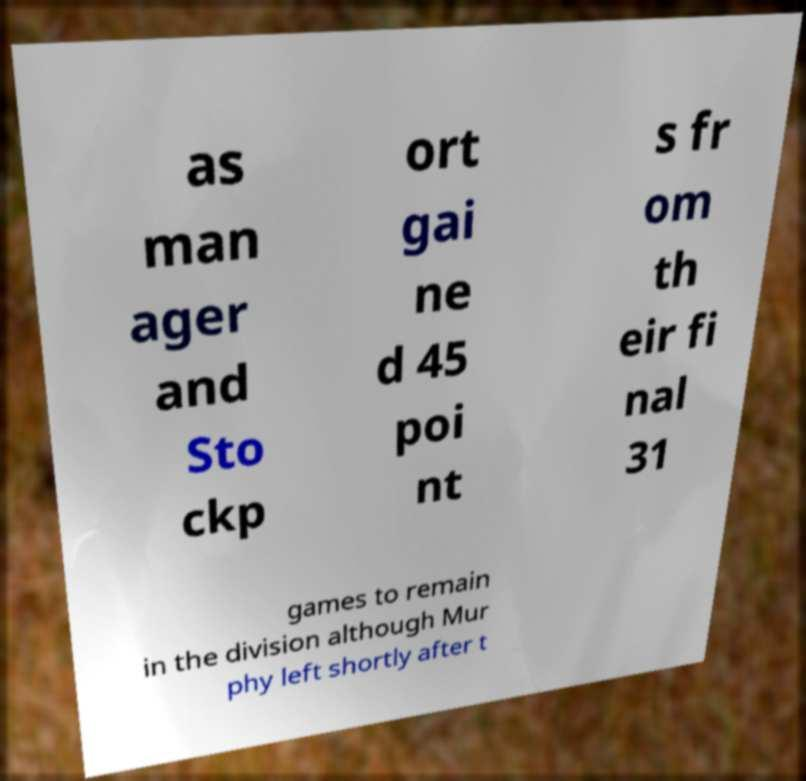Could you assist in decoding the text presented in this image and type it out clearly? as man ager and Sto ckp ort gai ne d 45 poi nt s fr om th eir fi nal 31 games to remain in the division although Mur phy left shortly after t 